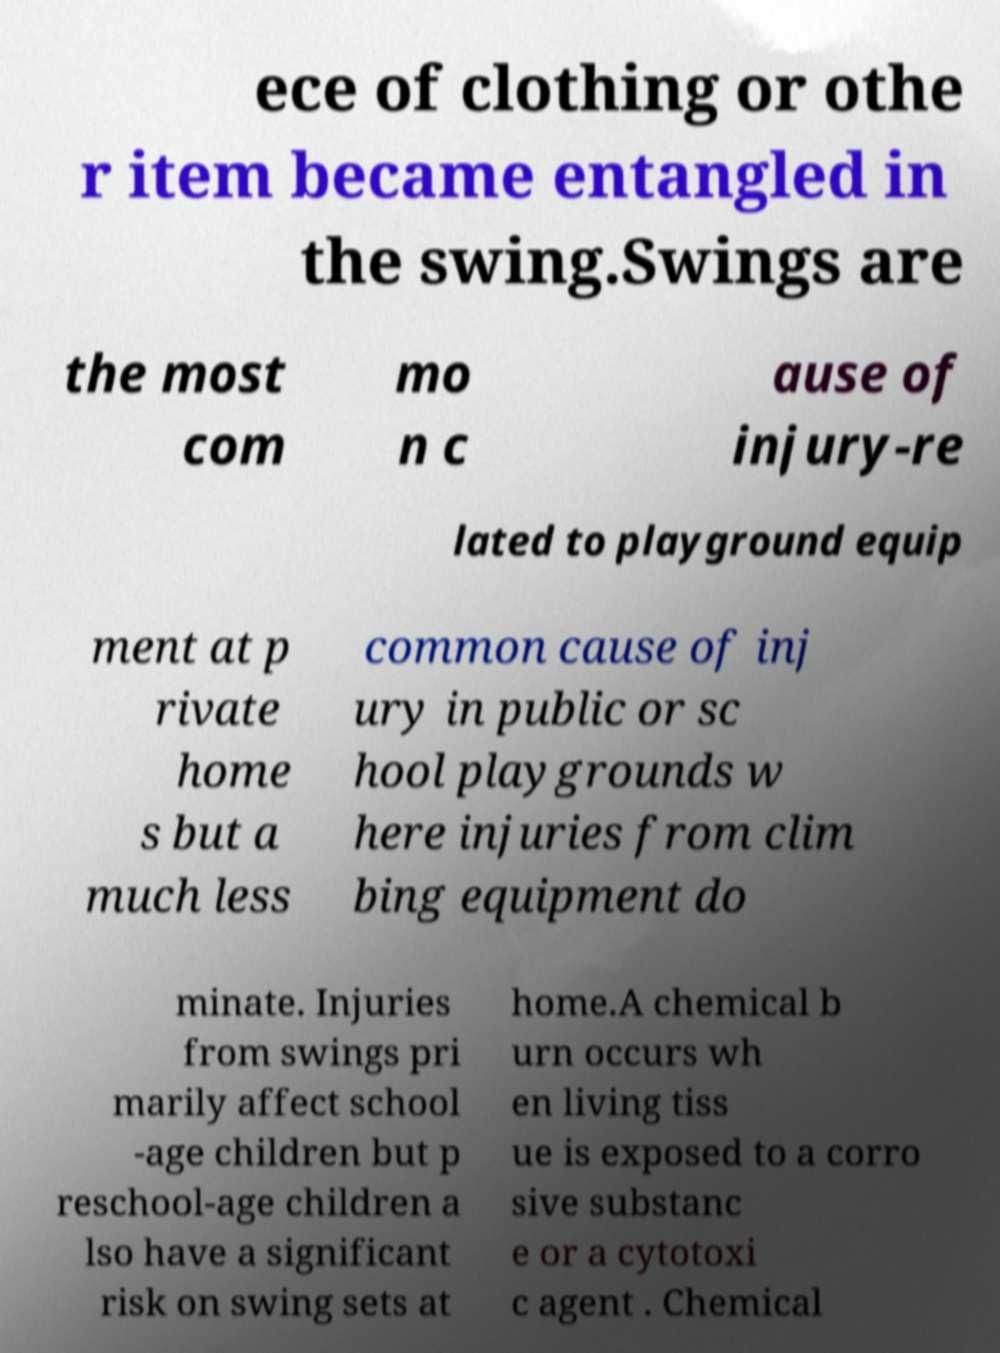Please identify and transcribe the text found in this image. ece of clothing or othe r item became entangled in the swing.Swings are the most com mo n c ause of injury-re lated to playground equip ment at p rivate home s but a much less common cause of inj ury in public or sc hool playgrounds w here injuries from clim bing equipment do minate. Injuries from swings pri marily affect school -age children but p reschool-age children a lso have a significant risk on swing sets at home.A chemical b urn occurs wh en living tiss ue is exposed to a corro sive substanc e or a cytotoxi c agent . Chemical 